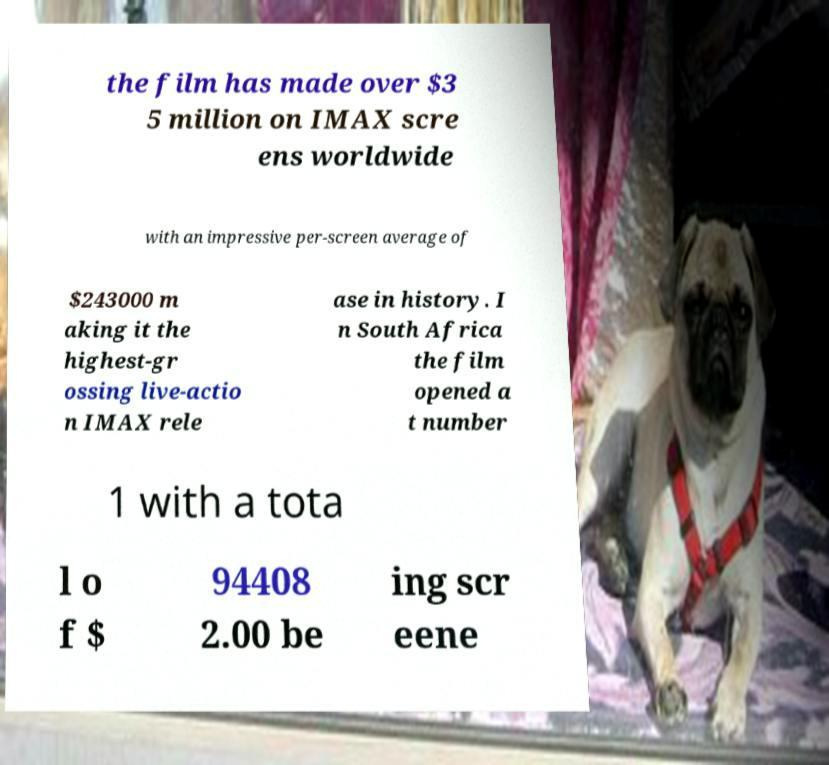Please identify and transcribe the text found in this image. the film has made over $3 5 million on IMAX scre ens worldwide with an impressive per-screen average of $243000 m aking it the highest-gr ossing live-actio n IMAX rele ase in history. I n South Africa the film opened a t number 1 with a tota l o f $ 94408 2.00 be ing scr eene 